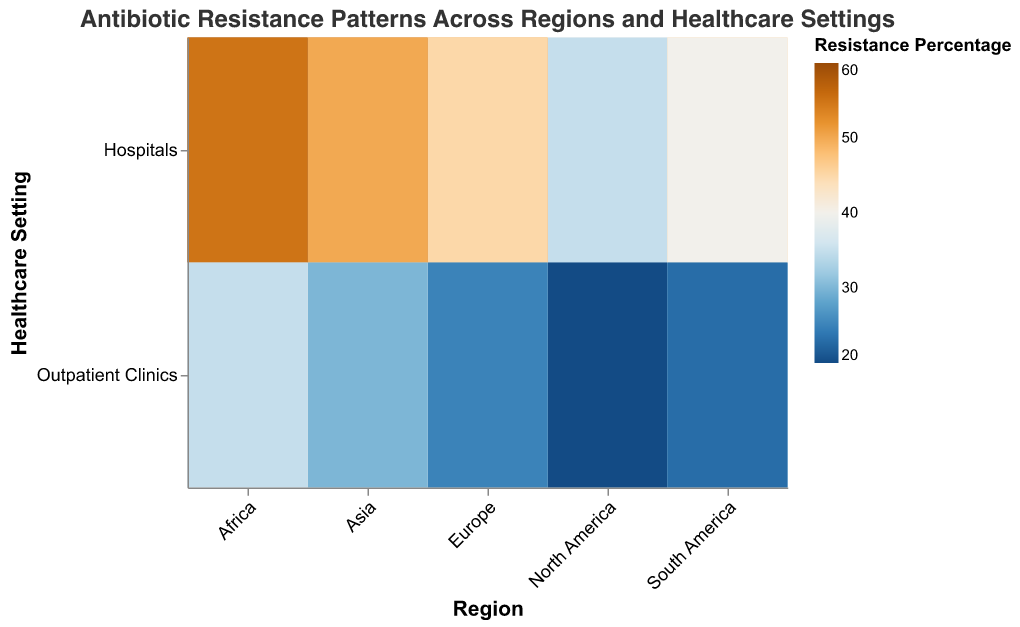What's the highest resistance percentage for Penicillin in hospitals? Look at the heatmap and identify the highest color intensity for Penicillin in hospitals. The highest percentage value should be visible at Africa Hospitals, which is 60.
Answer: 60 What's the average antibiotic resistance percentage for Methicillin in outpatient clinics across all regions? Sum the resistance percentages for Methicillin in outpatient clinics for all regions: 20 (North America) + 25 (Europe) + 30 (Asia) + 35 (Africa) + 23 (South America) = 133. Divide the sum by the number of regions (5): 133 / 5 = 26.6.
Answer: 26.6 Which healthcare setting in North America has a higher resistance percentage to Methicillin? Compare the colored boxes for Methicillin within the North America region between Hospitals and Outpatient Clinics. Resistance is 35% in hospitals and 20% in outpatient clinics.
Answer: Hospitals In which region is the resistance percentage to Penicillin in outpatient clinics the lowest? Identify the region with the lowest color intensity for Penicillin in outpatient clinics. North America shows the lowest value, which is 25%.
Answer: North America Which region has no resistance percentage value exceeding 50% in outpatient clinics for both antibiotics? Check each region for outpatient clinics to see if resistance percentages for both Penicillin and Methicillin exceed 50%. Look for the region (North America, South America, Europe) where none of the values exceed 50%.
Answer: South America How much higher is the resistance percentage to Penicillin in African hospitals compared to Asian outpatient clinics? Calculate the difference between the resistance percentages: 60 (African hospitals) - 35 (Asian outpatient clinics) = 25.
Answer: 25 For which antibiotic and in which healthcare setting is the highest resistance percentage observed in Europe? Look at the resistance percentages for both antibiotics in both healthcare settings within Europe. The highest value is for Penicillin in hospitals, which is 50%.
Answer: Penicillin in hospitals What's the difference between the highest and lowest resistance percentages for Methicillin in any setting across all regions? Identify the highest resistance percentage for Methicillin (55 in African hospitals) and the lowest (20 in North American outpatient clinics). Difference: 55 - 20 = 35.
Answer: 35 